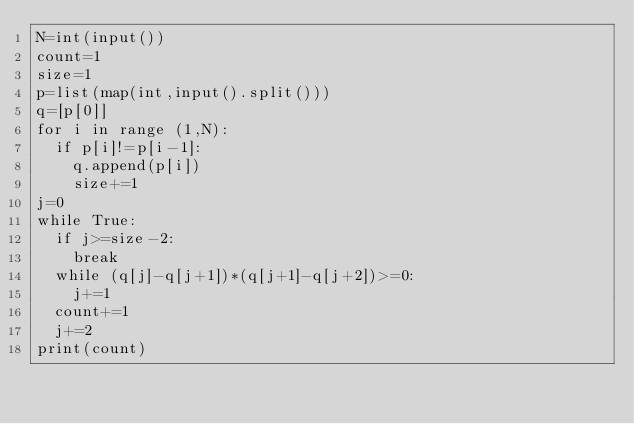Convert code to text. <code><loc_0><loc_0><loc_500><loc_500><_Python_>N=int(input())
count=1
size=1
p=list(map(int,input().split()))
q=[p[0]]
for i in range (1,N):
  if p[i]!=p[i-1]:
    q.append(p[i])
    size+=1
j=0
while True:
  if j>=size-2:
    break
  while (q[j]-q[j+1])*(q[j+1]-q[j+2])>=0:
    j+=1
  count+=1
  j+=2
print(count)</code> 